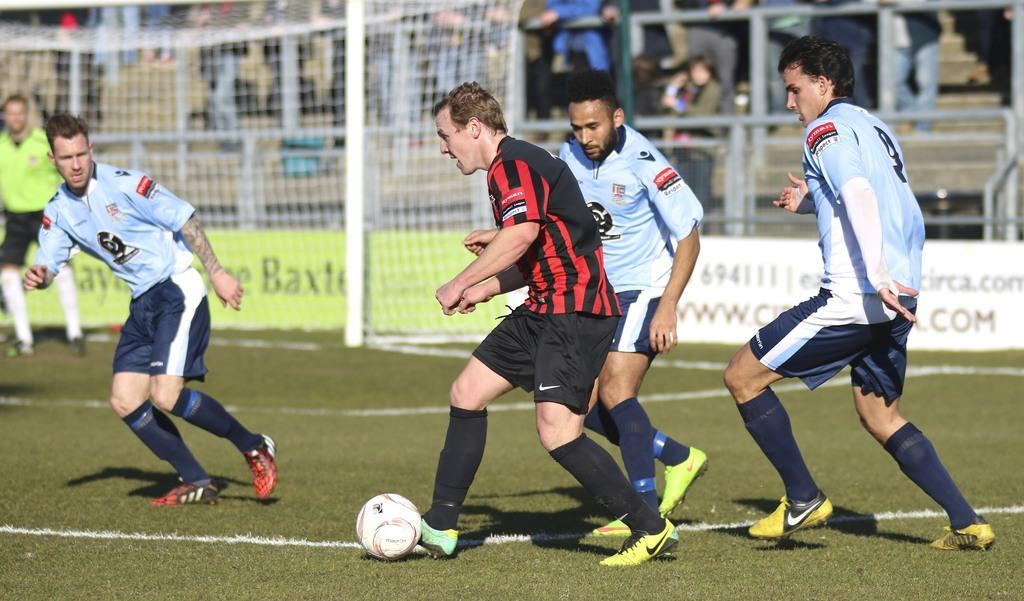Who or what is present in the image? There are people in the image. What are the people doing in the image? The people are playing with a football. Can you see a railway in the image? No, there is no railway present in the image. Is there a rainstorm happening in the image? No, there is no rainstorm depicted in the image. 